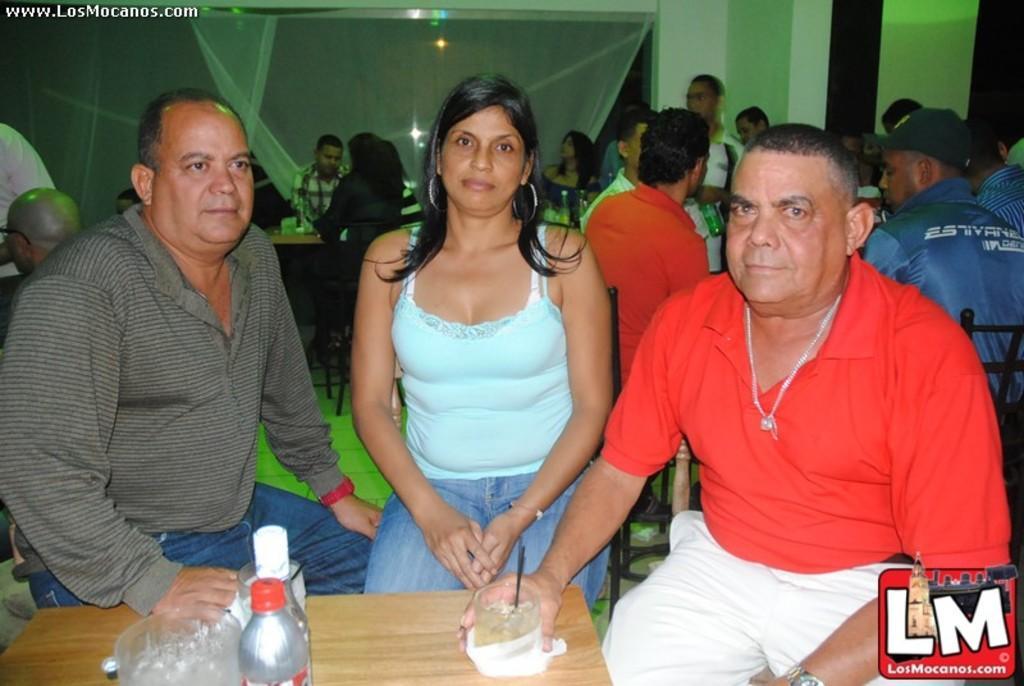Could you give a brief overview of what you see in this image? In this picture there are three people sitting on the chair in front of the table on which there are something things. 